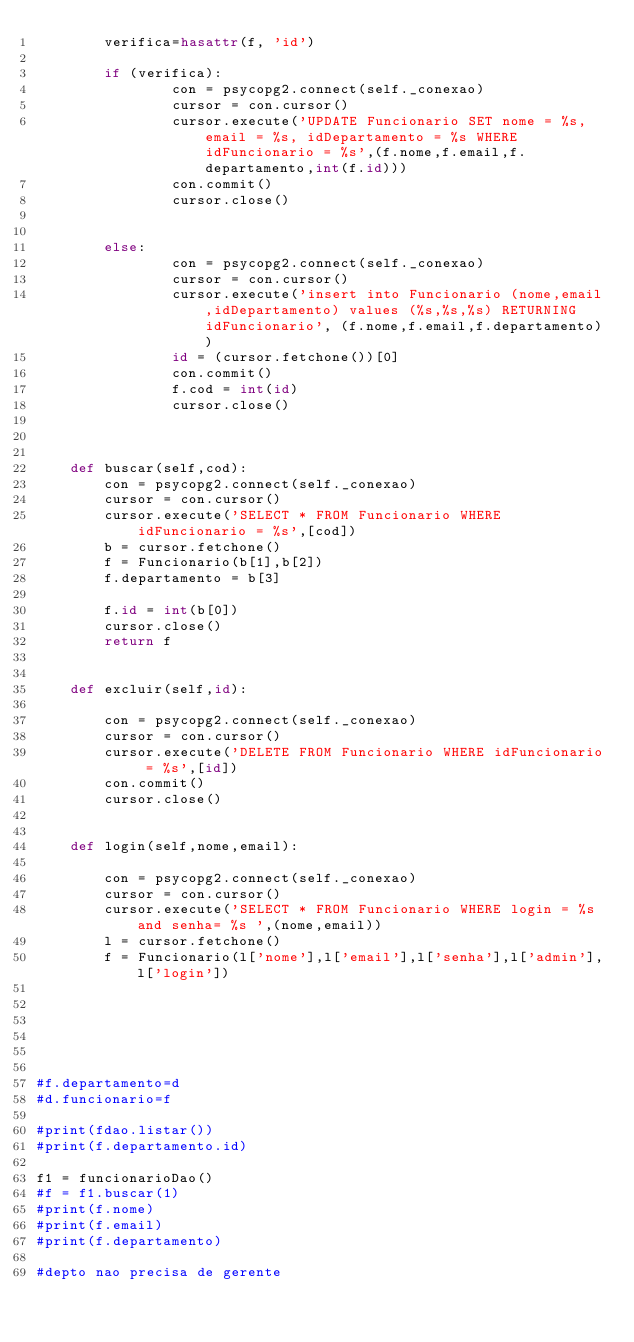Convert code to text. <code><loc_0><loc_0><loc_500><loc_500><_Python_>        verifica=hasattr(f, 'id')

        if (verifica):
                con = psycopg2.connect(self._conexao)
                cursor = con.cursor()
                cursor.execute('UPDATE Funcionario SET nome = %s, email = %s, idDepartamento = %s WHERE idFuncionario = %s',(f.nome,f.email,f.departamento,int(f.id)))
                con.commit()
                cursor.close()


        else:
                con = psycopg2.connect(self._conexao)
                cursor = con.cursor()
                cursor.execute('insert into Funcionario (nome,email,idDepartamento) values (%s,%s,%s) RETURNING idFuncionario', (f.nome,f.email,f.departamento))
                id = (cursor.fetchone())[0]
                con.commit()
                f.cod = int(id)
                cursor.close()



    def buscar(self,cod):
        con = psycopg2.connect(self._conexao)
        cursor = con.cursor()
        cursor.execute('SELECT * FROM Funcionario WHERE idFuncionario = %s',[cod])
        b = cursor.fetchone()
        f = Funcionario(b[1],b[2])
        f.departamento = b[3]
		
        f.id = int(b[0])
        cursor.close()
        return f


    def excluir(self,id):

        con = psycopg2.connect(self._conexao)
        cursor = con.cursor()
        cursor.execute('DELETE FROM Funcionario WHERE idFuncionario = %s',[id])
        con.commit()
        cursor.close()


    def login(self,nome,email):

        con = psycopg2.connect(self._conexao)
        cursor = con.cursor()
        cursor.execute('SELECT * FROM Funcionario WHERE login = %s and senha= %s ',(nome,email))
        l = cursor.fetchone()
        f = Funcionario(l['nome'],l['email'],l['senha'],l['admin'],l['login'])






#f.departamento=d
#d.funcionario=f

#print(fdao.listar())
#print(f.departamento.id)

f1 = funcionarioDao()
#f = f1.buscar(1)
#print(f.nome)
#print(f.email)
#print(f.departamento)

#depto nao precisa de gerente



 





</code> 